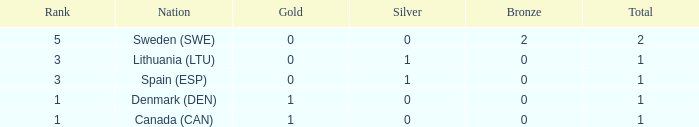How many bronze medals were won when the total is more than 1, and gold is more than 0? None. 